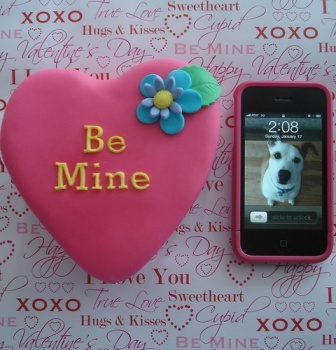Describe the following image. The image features a delightful Valentine's Day setting emphasizing affection and celebration. Center stage is a large, heart-shaped cookie painted in a vivid pink hue, elegantly inscribed with 'Be Mine' in a bold red script. Beside the cookie, there is a pink iPhone which displays the time and a snapshot of a white dog that adds a personal and adorable touch to the setup. The backdrop is a paper filled with romantic and festive phrases like 'Hugs & Kisses', 'XOXO', and 'Sweetheart', set in tones of red and pink which compliment the central theme. Together, these elements blend harmoniously, creating not just a visually appealing scene, but also evoking the spirit of love and personal connection inherent to the holiday. 